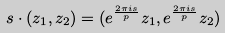Convert formula to latex. <formula><loc_0><loc_0><loc_500><loc_500>s \cdot ( z _ { 1 } , z _ { 2 } ) = ( e ^ { \frac { 2 \pi i s } { p } } z _ { 1 } , e ^ { \frac { 2 \pi i s } { p } } z _ { 2 } )</formula> 